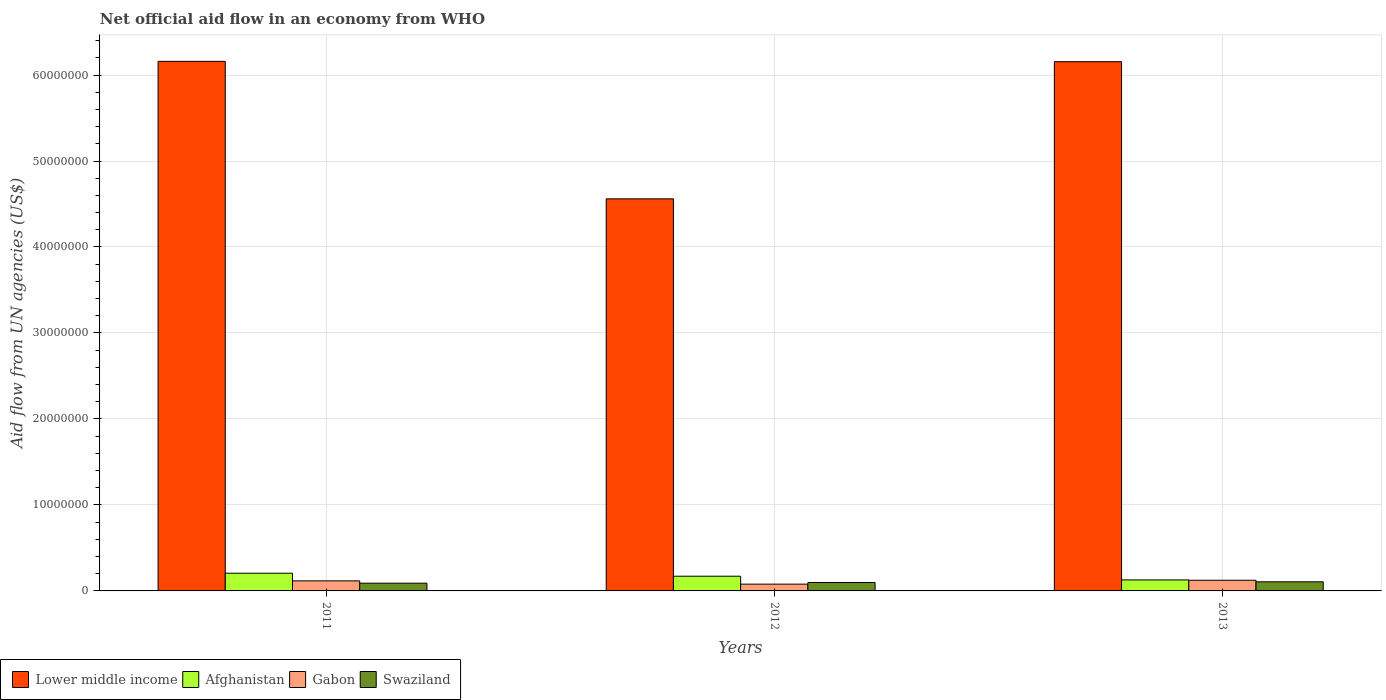Are the number of bars per tick equal to the number of legend labels?
Offer a very short reply. Yes. Are the number of bars on each tick of the X-axis equal?
Offer a very short reply. Yes. How many bars are there on the 2nd tick from the right?
Your answer should be compact. 4. What is the label of the 1st group of bars from the left?
Provide a succinct answer. 2011. In how many cases, is the number of bars for a given year not equal to the number of legend labels?
Ensure brevity in your answer.  0. What is the net official aid flow in Lower middle income in 2011?
Ensure brevity in your answer.  6.16e+07. Across all years, what is the maximum net official aid flow in Swaziland?
Offer a very short reply. 1.06e+06. What is the total net official aid flow in Gabon in the graph?
Offer a terse response. 3.20e+06. What is the difference between the net official aid flow in Lower middle income in 2012 and the net official aid flow in Afghanistan in 2013?
Offer a terse response. 4.43e+07. What is the average net official aid flow in Lower middle income per year?
Provide a succinct answer. 5.62e+07. In the year 2012, what is the difference between the net official aid flow in Lower middle income and net official aid flow in Gabon?
Provide a succinct answer. 4.48e+07. In how many years, is the net official aid flow in Swaziland greater than 8000000 US$?
Make the answer very short. 0. What is the ratio of the net official aid flow in Gabon in 2011 to that in 2013?
Ensure brevity in your answer.  0.94. What is the difference between the highest and the second highest net official aid flow in Swaziland?
Make the answer very short. 8.00e+04. What is the difference between the highest and the lowest net official aid flow in Swaziland?
Offer a very short reply. 1.60e+05. In how many years, is the net official aid flow in Afghanistan greater than the average net official aid flow in Afghanistan taken over all years?
Offer a very short reply. 2. Is it the case that in every year, the sum of the net official aid flow in Swaziland and net official aid flow in Afghanistan is greater than the sum of net official aid flow in Lower middle income and net official aid flow in Gabon?
Keep it short and to the point. No. What does the 3rd bar from the left in 2012 represents?
Ensure brevity in your answer.  Gabon. What does the 2nd bar from the right in 2011 represents?
Your answer should be very brief. Gabon. What is the difference between two consecutive major ticks on the Y-axis?
Your answer should be very brief. 1.00e+07. Are the values on the major ticks of Y-axis written in scientific E-notation?
Make the answer very short. No. Where does the legend appear in the graph?
Your response must be concise. Bottom left. How many legend labels are there?
Your response must be concise. 4. How are the legend labels stacked?
Your answer should be compact. Horizontal. What is the title of the graph?
Give a very brief answer. Net official aid flow in an economy from WHO. What is the label or title of the Y-axis?
Your response must be concise. Aid flow from UN agencies (US$). What is the Aid flow from UN agencies (US$) of Lower middle income in 2011?
Offer a terse response. 6.16e+07. What is the Aid flow from UN agencies (US$) in Afghanistan in 2011?
Your answer should be very brief. 2.06e+06. What is the Aid flow from UN agencies (US$) of Gabon in 2011?
Offer a very short reply. 1.17e+06. What is the Aid flow from UN agencies (US$) in Swaziland in 2011?
Your answer should be compact. 9.00e+05. What is the Aid flow from UN agencies (US$) of Lower middle income in 2012?
Offer a terse response. 4.56e+07. What is the Aid flow from UN agencies (US$) of Afghanistan in 2012?
Make the answer very short. 1.71e+06. What is the Aid flow from UN agencies (US$) of Gabon in 2012?
Offer a very short reply. 7.90e+05. What is the Aid flow from UN agencies (US$) of Swaziland in 2012?
Make the answer very short. 9.80e+05. What is the Aid flow from UN agencies (US$) in Lower middle income in 2013?
Provide a succinct answer. 6.16e+07. What is the Aid flow from UN agencies (US$) of Afghanistan in 2013?
Your answer should be compact. 1.28e+06. What is the Aid flow from UN agencies (US$) of Gabon in 2013?
Offer a terse response. 1.24e+06. What is the Aid flow from UN agencies (US$) of Swaziland in 2013?
Provide a short and direct response. 1.06e+06. Across all years, what is the maximum Aid flow from UN agencies (US$) in Lower middle income?
Keep it short and to the point. 6.16e+07. Across all years, what is the maximum Aid flow from UN agencies (US$) of Afghanistan?
Offer a very short reply. 2.06e+06. Across all years, what is the maximum Aid flow from UN agencies (US$) of Gabon?
Give a very brief answer. 1.24e+06. Across all years, what is the maximum Aid flow from UN agencies (US$) of Swaziland?
Keep it short and to the point. 1.06e+06. Across all years, what is the minimum Aid flow from UN agencies (US$) of Lower middle income?
Make the answer very short. 4.56e+07. Across all years, what is the minimum Aid flow from UN agencies (US$) in Afghanistan?
Give a very brief answer. 1.28e+06. Across all years, what is the minimum Aid flow from UN agencies (US$) of Gabon?
Your answer should be very brief. 7.90e+05. Across all years, what is the minimum Aid flow from UN agencies (US$) in Swaziland?
Your answer should be very brief. 9.00e+05. What is the total Aid flow from UN agencies (US$) of Lower middle income in the graph?
Give a very brief answer. 1.69e+08. What is the total Aid flow from UN agencies (US$) of Afghanistan in the graph?
Give a very brief answer. 5.05e+06. What is the total Aid flow from UN agencies (US$) of Gabon in the graph?
Offer a terse response. 3.20e+06. What is the total Aid flow from UN agencies (US$) in Swaziland in the graph?
Provide a succinct answer. 2.94e+06. What is the difference between the Aid flow from UN agencies (US$) in Lower middle income in 2011 and that in 2012?
Give a very brief answer. 1.60e+07. What is the difference between the Aid flow from UN agencies (US$) of Swaziland in 2011 and that in 2012?
Your response must be concise. -8.00e+04. What is the difference between the Aid flow from UN agencies (US$) of Afghanistan in 2011 and that in 2013?
Keep it short and to the point. 7.80e+05. What is the difference between the Aid flow from UN agencies (US$) of Lower middle income in 2012 and that in 2013?
Provide a short and direct response. -1.60e+07. What is the difference between the Aid flow from UN agencies (US$) of Afghanistan in 2012 and that in 2013?
Provide a short and direct response. 4.30e+05. What is the difference between the Aid flow from UN agencies (US$) of Gabon in 2012 and that in 2013?
Your answer should be very brief. -4.50e+05. What is the difference between the Aid flow from UN agencies (US$) of Swaziland in 2012 and that in 2013?
Keep it short and to the point. -8.00e+04. What is the difference between the Aid flow from UN agencies (US$) in Lower middle income in 2011 and the Aid flow from UN agencies (US$) in Afghanistan in 2012?
Ensure brevity in your answer.  5.99e+07. What is the difference between the Aid flow from UN agencies (US$) in Lower middle income in 2011 and the Aid flow from UN agencies (US$) in Gabon in 2012?
Provide a succinct answer. 6.08e+07. What is the difference between the Aid flow from UN agencies (US$) of Lower middle income in 2011 and the Aid flow from UN agencies (US$) of Swaziland in 2012?
Make the answer very short. 6.06e+07. What is the difference between the Aid flow from UN agencies (US$) of Afghanistan in 2011 and the Aid flow from UN agencies (US$) of Gabon in 2012?
Your answer should be compact. 1.27e+06. What is the difference between the Aid flow from UN agencies (US$) of Afghanistan in 2011 and the Aid flow from UN agencies (US$) of Swaziland in 2012?
Provide a short and direct response. 1.08e+06. What is the difference between the Aid flow from UN agencies (US$) of Gabon in 2011 and the Aid flow from UN agencies (US$) of Swaziland in 2012?
Give a very brief answer. 1.90e+05. What is the difference between the Aid flow from UN agencies (US$) of Lower middle income in 2011 and the Aid flow from UN agencies (US$) of Afghanistan in 2013?
Make the answer very short. 6.03e+07. What is the difference between the Aid flow from UN agencies (US$) of Lower middle income in 2011 and the Aid flow from UN agencies (US$) of Gabon in 2013?
Your answer should be very brief. 6.04e+07. What is the difference between the Aid flow from UN agencies (US$) of Lower middle income in 2011 and the Aid flow from UN agencies (US$) of Swaziland in 2013?
Provide a short and direct response. 6.05e+07. What is the difference between the Aid flow from UN agencies (US$) of Afghanistan in 2011 and the Aid flow from UN agencies (US$) of Gabon in 2013?
Keep it short and to the point. 8.20e+05. What is the difference between the Aid flow from UN agencies (US$) of Afghanistan in 2011 and the Aid flow from UN agencies (US$) of Swaziland in 2013?
Your answer should be compact. 1.00e+06. What is the difference between the Aid flow from UN agencies (US$) in Gabon in 2011 and the Aid flow from UN agencies (US$) in Swaziland in 2013?
Keep it short and to the point. 1.10e+05. What is the difference between the Aid flow from UN agencies (US$) of Lower middle income in 2012 and the Aid flow from UN agencies (US$) of Afghanistan in 2013?
Give a very brief answer. 4.43e+07. What is the difference between the Aid flow from UN agencies (US$) in Lower middle income in 2012 and the Aid flow from UN agencies (US$) in Gabon in 2013?
Offer a terse response. 4.44e+07. What is the difference between the Aid flow from UN agencies (US$) in Lower middle income in 2012 and the Aid flow from UN agencies (US$) in Swaziland in 2013?
Your response must be concise. 4.45e+07. What is the difference between the Aid flow from UN agencies (US$) of Afghanistan in 2012 and the Aid flow from UN agencies (US$) of Gabon in 2013?
Your answer should be very brief. 4.70e+05. What is the difference between the Aid flow from UN agencies (US$) in Afghanistan in 2012 and the Aid flow from UN agencies (US$) in Swaziland in 2013?
Provide a succinct answer. 6.50e+05. What is the difference between the Aid flow from UN agencies (US$) in Gabon in 2012 and the Aid flow from UN agencies (US$) in Swaziland in 2013?
Offer a very short reply. -2.70e+05. What is the average Aid flow from UN agencies (US$) of Lower middle income per year?
Provide a short and direct response. 5.62e+07. What is the average Aid flow from UN agencies (US$) in Afghanistan per year?
Ensure brevity in your answer.  1.68e+06. What is the average Aid flow from UN agencies (US$) in Gabon per year?
Your response must be concise. 1.07e+06. What is the average Aid flow from UN agencies (US$) in Swaziland per year?
Offer a very short reply. 9.80e+05. In the year 2011, what is the difference between the Aid flow from UN agencies (US$) of Lower middle income and Aid flow from UN agencies (US$) of Afghanistan?
Your answer should be very brief. 5.95e+07. In the year 2011, what is the difference between the Aid flow from UN agencies (US$) of Lower middle income and Aid flow from UN agencies (US$) of Gabon?
Make the answer very short. 6.04e+07. In the year 2011, what is the difference between the Aid flow from UN agencies (US$) of Lower middle income and Aid flow from UN agencies (US$) of Swaziland?
Ensure brevity in your answer.  6.07e+07. In the year 2011, what is the difference between the Aid flow from UN agencies (US$) of Afghanistan and Aid flow from UN agencies (US$) of Gabon?
Your answer should be compact. 8.90e+05. In the year 2011, what is the difference between the Aid flow from UN agencies (US$) in Afghanistan and Aid flow from UN agencies (US$) in Swaziland?
Make the answer very short. 1.16e+06. In the year 2012, what is the difference between the Aid flow from UN agencies (US$) of Lower middle income and Aid flow from UN agencies (US$) of Afghanistan?
Provide a succinct answer. 4.39e+07. In the year 2012, what is the difference between the Aid flow from UN agencies (US$) of Lower middle income and Aid flow from UN agencies (US$) of Gabon?
Offer a very short reply. 4.48e+07. In the year 2012, what is the difference between the Aid flow from UN agencies (US$) of Lower middle income and Aid flow from UN agencies (US$) of Swaziland?
Your response must be concise. 4.46e+07. In the year 2012, what is the difference between the Aid flow from UN agencies (US$) in Afghanistan and Aid flow from UN agencies (US$) in Gabon?
Give a very brief answer. 9.20e+05. In the year 2012, what is the difference between the Aid flow from UN agencies (US$) in Afghanistan and Aid flow from UN agencies (US$) in Swaziland?
Give a very brief answer. 7.30e+05. In the year 2013, what is the difference between the Aid flow from UN agencies (US$) in Lower middle income and Aid flow from UN agencies (US$) in Afghanistan?
Offer a very short reply. 6.03e+07. In the year 2013, what is the difference between the Aid flow from UN agencies (US$) in Lower middle income and Aid flow from UN agencies (US$) in Gabon?
Provide a succinct answer. 6.03e+07. In the year 2013, what is the difference between the Aid flow from UN agencies (US$) in Lower middle income and Aid flow from UN agencies (US$) in Swaziland?
Offer a very short reply. 6.05e+07. In the year 2013, what is the difference between the Aid flow from UN agencies (US$) in Afghanistan and Aid flow from UN agencies (US$) in Swaziland?
Offer a very short reply. 2.20e+05. In the year 2013, what is the difference between the Aid flow from UN agencies (US$) in Gabon and Aid flow from UN agencies (US$) in Swaziland?
Your answer should be compact. 1.80e+05. What is the ratio of the Aid flow from UN agencies (US$) in Lower middle income in 2011 to that in 2012?
Your response must be concise. 1.35. What is the ratio of the Aid flow from UN agencies (US$) in Afghanistan in 2011 to that in 2012?
Provide a short and direct response. 1.2. What is the ratio of the Aid flow from UN agencies (US$) in Gabon in 2011 to that in 2012?
Ensure brevity in your answer.  1.48. What is the ratio of the Aid flow from UN agencies (US$) of Swaziland in 2011 to that in 2012?
Your response must be concise. 0.92. What is the ratio of the Aid flow from UN agencies (US$) in Afghanistan in 2011 to that in 2013?
Your answer should be very brief. 1.61. What is the ratio of the Aid flow from UN agencies (US$) of Gabon in 2011 to that in 2013?
Ensure brevity in your answer.  0.94. What is the ratio of the Aid flow from UN agencies (US$) in Swaziland in 2011 to that in 2013?
Your answer should be compact. 0.85. What is the ratio of the Aid flow from UN agencies (US$) of Lower middle income in 2012 to that in 2013?
Your answer should be very brief. 0.74. What is the ratio of the Aid flow from UN agencies (US$) of Afghanistan in 2012 to that in 2013?
Provide a short and direct response. 1.34. What is the ratio of the Aid flow from UN agencies (US$) in Gabon in 2012 to that in 2013?
Keep it short and to the point. 0.64. What is the ratio of the Aid flow from UN agencies (US$) of Swaziland in 2012 to that in 2013?
Make the answer very short. 0.92. What is the difference between the highest and the second highest Aid flow from UN agencies (US$) in Afghanistan?
Keep it short and to the point. 3.50e+05. What is the difference between the highest and the lowest Aid flow from UN agencies (US$) of Lower middle income?
Your answer should be very brief. 1.60e+07. What is the difference between the highest and the lowest Aid flow from UN agencies (US$) in Afghanistan?
Offer a terse response. 7.80e+05. What is the difference between the highest and the lowest Aid flow from UN agencies (US$) in Swaziland?
Ensure brevity in your answer.  1.60e+05. 